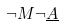Convert formula to latex. <formula><loc_0><loc_0><loc_500><loc_500>\neg M \neg \underline { A }</formula> 